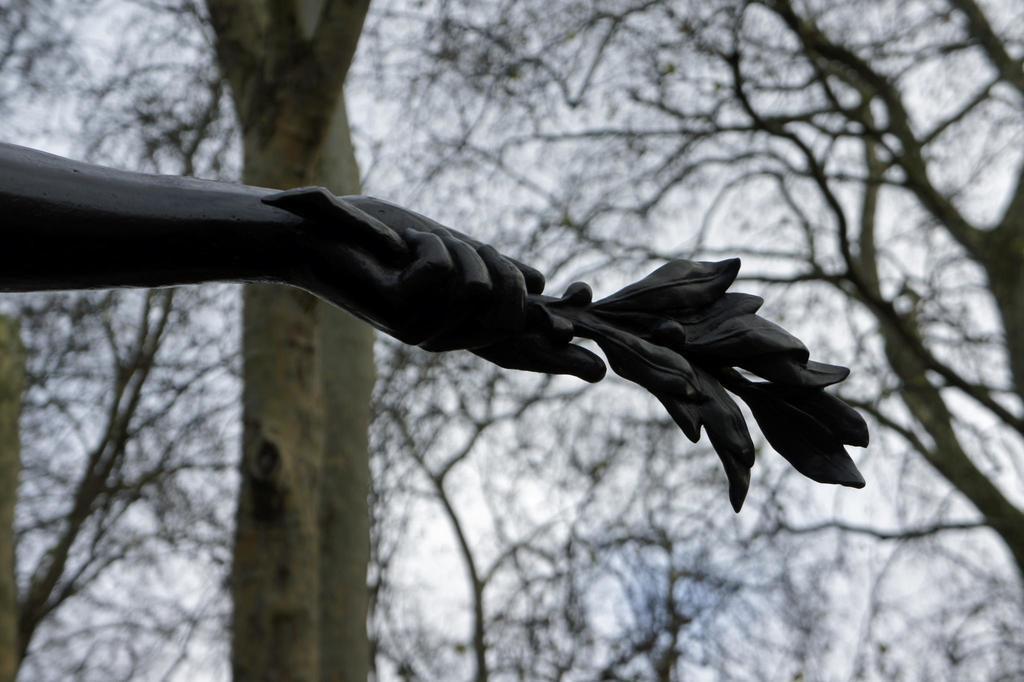Can you describe this image briefly? In this image, on the left side, we can see hand of a statue holding some object. In the background, we can see some trees and a sky. 